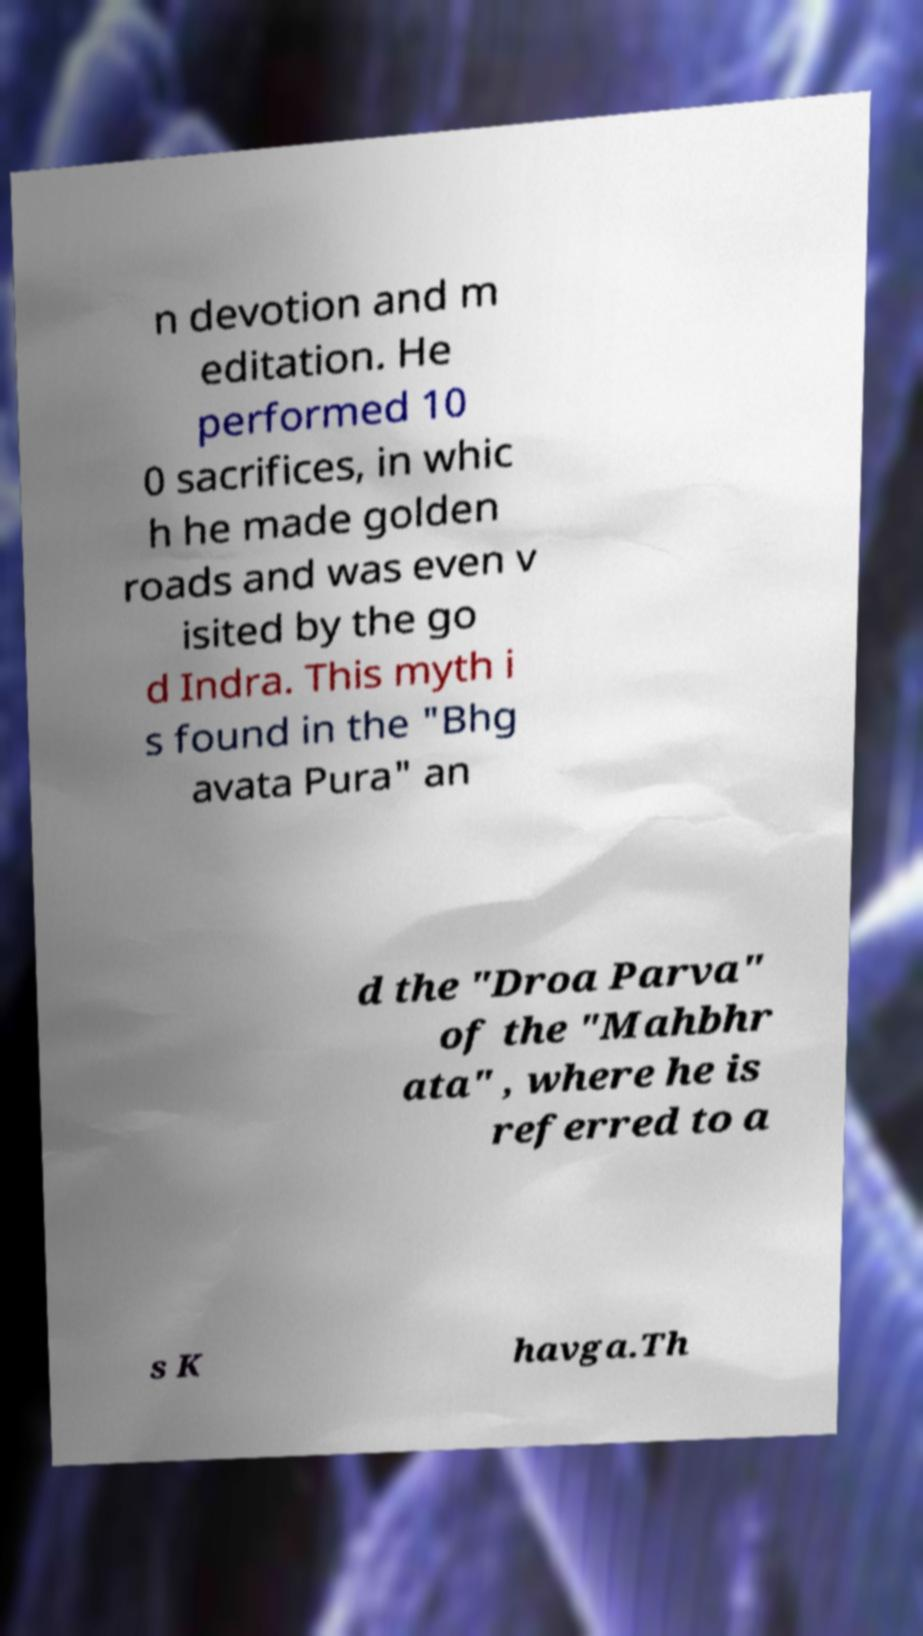I need the written content from this picture converted into text. Can you do that? n devotion and m editation. He performed 10 0 sacrifices, in whic h he made golden roads and was even v isited by the go d Indra. This myth i s found in the "Bhg avata Pura" an d the "Droa Parva" of the "Mahbhr ata" , where he is referred to a s K havga.Th 